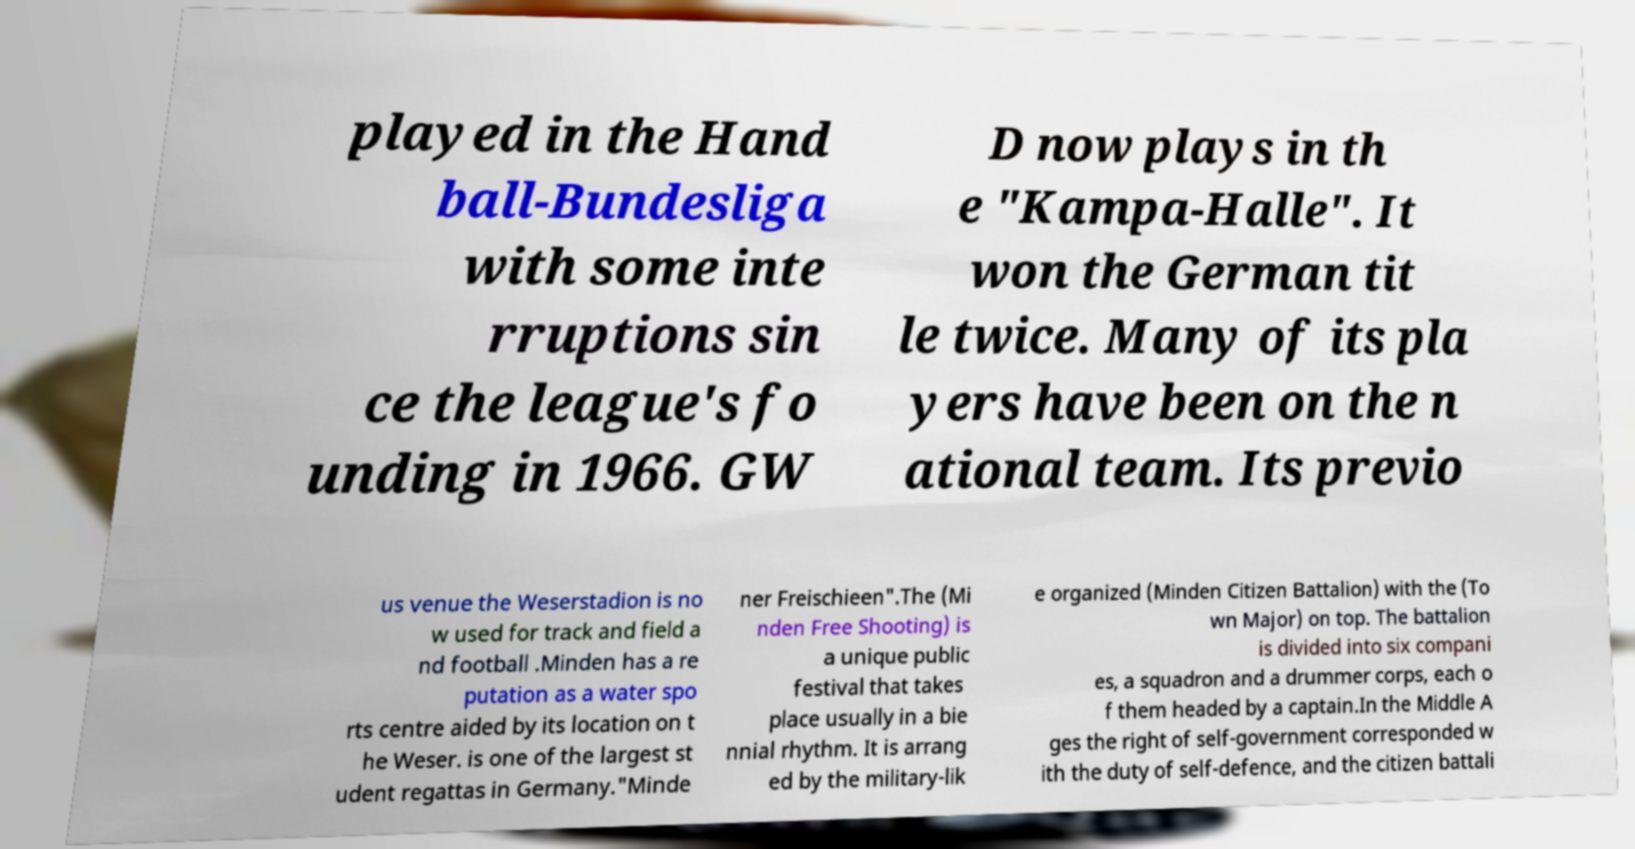Please identify and transcribe the text found in this image. played in the Hand ball-Bundesliga with some inte rruptions sin ce the league's fo unding in 1966. GW D now plays in th e "Kampa-Halle". It won the German tit le twice. Many of its pla yers have been on the n ational team. Its previo us venue the Weserstadion is no w used for track and field a nd football .Minden has a re putation as a water spo rts centre aided by its location on t he Weser. is one of the largest st udent regattas in Germany."Minde ner Freischieen".The (Mi nden Free Shooting) is a unique public festival that takes place usually in a bie nnial rhythm. It is arrang ed by the military-lik e organized (Minden Citizen Battalion) with the (To wn Major) on top. The battalion is divided into six compani es, a squadron and a drummer corps, each o f them headed by a captain.In the Middle A ges the right of self-government corresponded w ith the duty of self-defence, and the citizen battali 